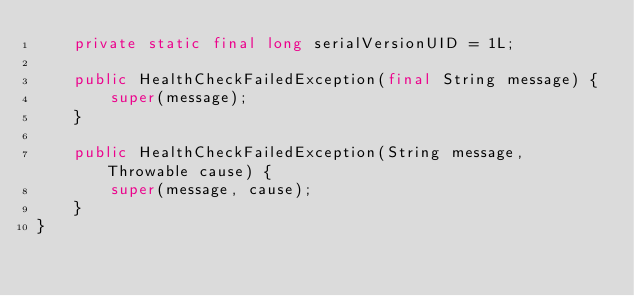Convert code to text. <code><loc_0><loc_0><loc_500><loc_500><_Java_>    private static final long serialVersionUID = 1L;

    public HealthCheckFailedException(final String message) {
        super(message);
    }

    public HealthCheckFailedException(String message, Throwable cause) {
        super(message, cause);
    }
}
</code> 